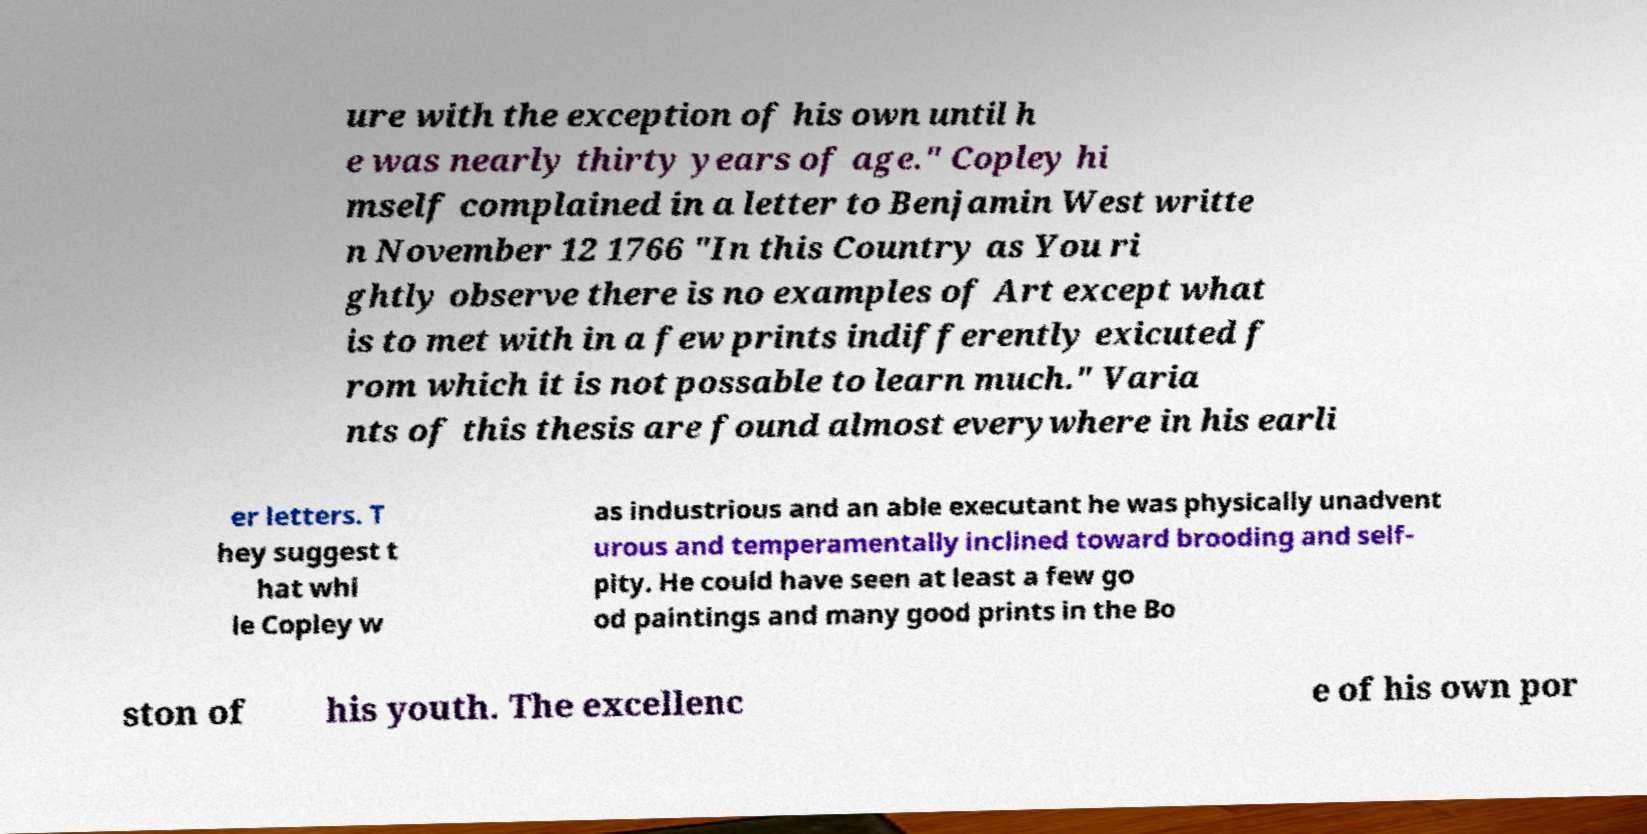I need the written content from this picture converted into text. Can you do that? ure with the exception of his own until h e was nearly thirty years of age." Copley hi mself complained in a letter to Benjamin West writte n November 12 1766 "In this Country as You ri ghtly observe there is no examples of Art except what is to met with in a few prints indifferently exicuted f rom which it is not possable to learn much." Varia nts of this thesis are found almost everywhere in his earli er letters. T hey suggest t hat whi le Copley w as industrious and an able executant he was physically unadvent urous and temperamentally inclined toward brooding and self- pity. He could have seen at least a few go od paintings and many good prints in the Bo ston of his youth. The excellenc e of his own por 